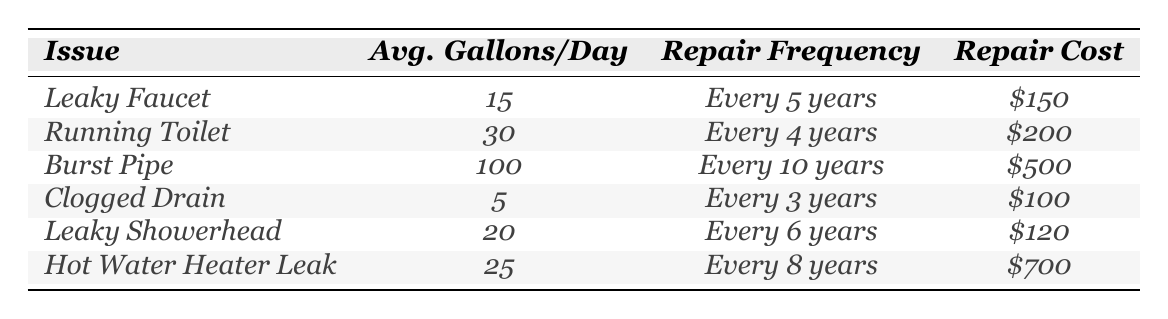What's the average gallons of water used per day by a leaky faucet? The table indicates that a leaky faucet uses an average of 15 gallons of water per day.
Answer: 15 How often must a running toilet be repaired? The table states that a running toilet needs repairs every 4 years.
Answer: Every 4 years What is the repair cost for a clogged drain? According to the table, the repair cost for a clogged drain is $100.
Answer: $100 Which plumbing issue uses the most water per day? The table shows that a burst pipe uses 100 gallons per day, which is the highest among all listed issues.
Answer: Burst Pipe How many gallons of water does a leaky showerhead waste compared to a clogged drain? A leaky showerhead uses 20 gallons per day, while a clogged drain uses 5 gallons. The difference is 20 - 5 = 15 gallons per day.
Answer: 15 gallons Does a hot water heater leak have a higher repair frequency than a leaky faucet? The table lists the hot water heater leak's repair frequency as every 8 years and the leaky faucet's as every 5 years, indicating that the leaky faucet has a higher repair frequency.
Answer: No What is the total average water usage per day for all plumbing issues listed? To find the total average usage, sum the average gallons per day: 15 + 30 + 100 + 5 + 20 + 25 = 195 gallons per day.
Answer: 195 gallons Is the repair cost for a hot water heater leak the highest among all listed plumbing issues? Comparing all the costs in the table, the hot water heater leak's cost of $700 is indeed the highest.
Answer: Yes What is the average interval for repairs among all plumbing issues? First, add the intervals of each repair: (5 + 4 + 10 + 3 + 6 + 8) = 36 years. Then divide by the number of issues (6) to find the average: 36/6 = 6 years.
Answer: 6 years If someone uses only a leaky showerhead for one year, how many gallons of water will be wasted? The average gallons used per day by a leaky showerhead is 20. For a year, multiply by 365 days: 20 * 365 = 7300 gallons.
Answer: 7300 gallons What plumbing issue occurs the least frequently? The table shows that the issue with the highest repair frequency is a burst pipe, needing repairs every 10 years, which means it occurs the least often.
Answer: Burst Pipe 